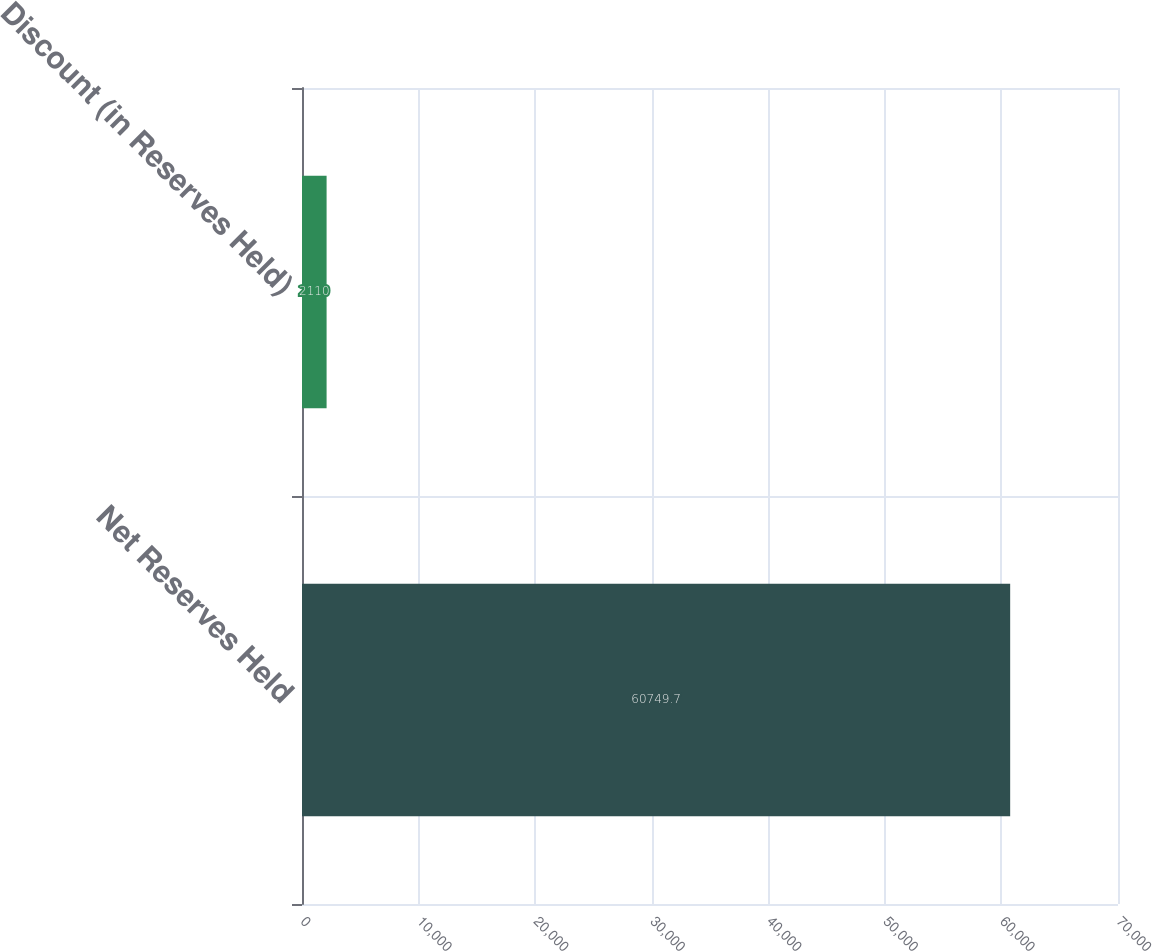Convert chart to OTSL. <chart><loc_0><loc_0><loc_500><loc_500><bar_chart><fcel>Net Reserves Held<fcel>Discount (in Reserves Held)<nl><fcel>60749.7<fcel>2110<nl></chart> 